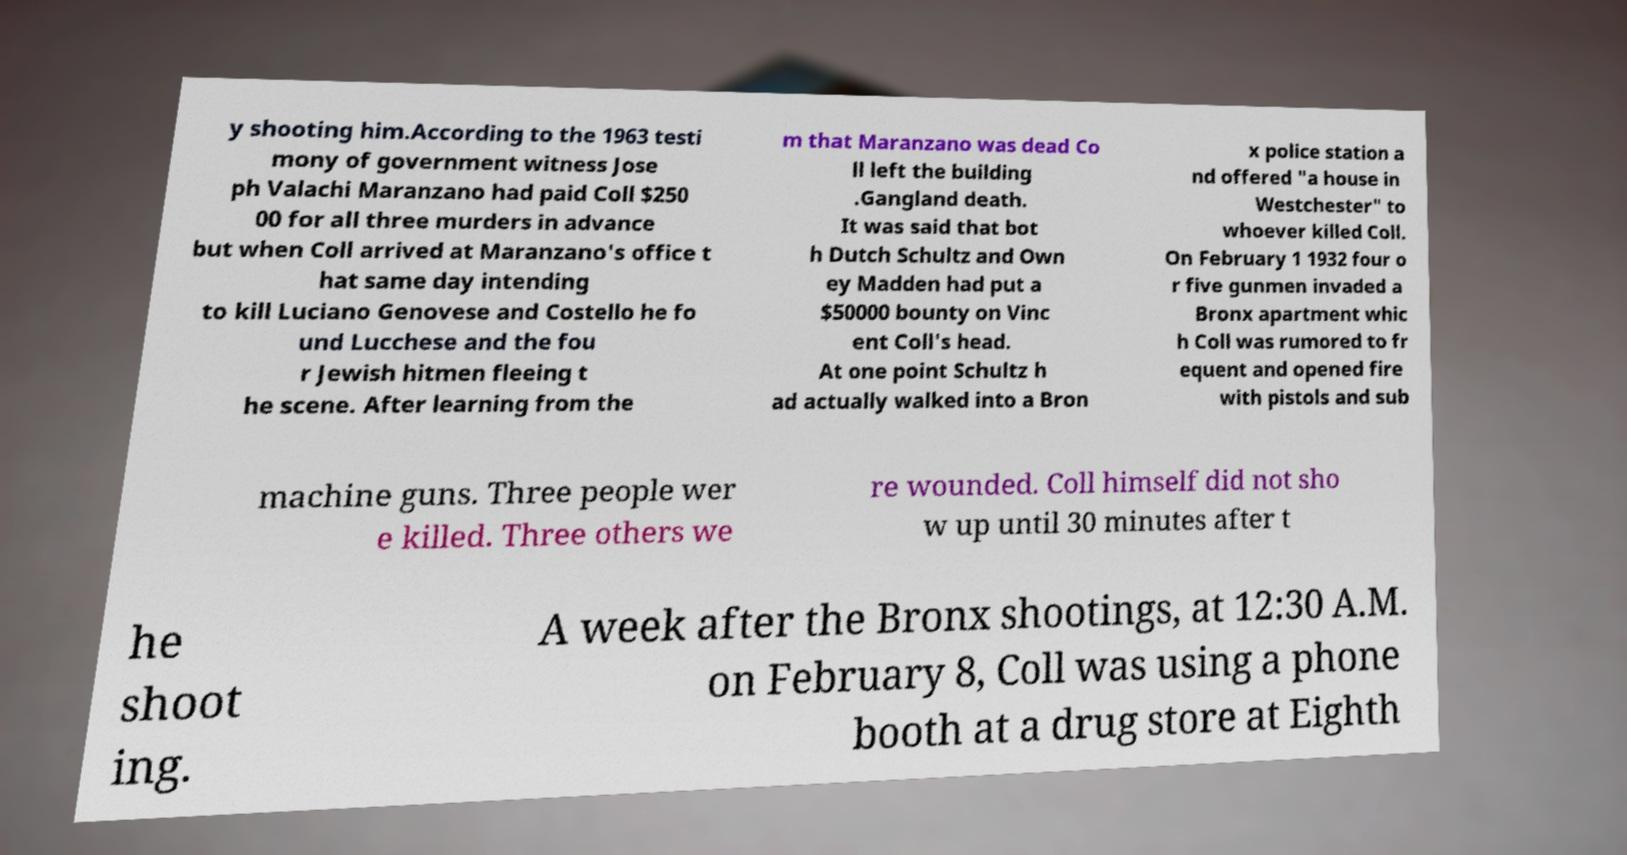I need the written content from this picture converted into text. Can you do that? y shooting him.According to the 1963 testi mony of government witness Jose ph Valachi Maranzano had paid Coll $250 00 for all three murders in advance but when Coll arrived at Maranzano's office t hat same day intending to kill Luciano Genovese and Costello he fo und Lucchese and the fou r Jewish hitmen fleeing t he scene. After learning from the m that Maranzano was dead Co ll left the building .Gangland death. It was said that bot h Dutch Schultz and Own ey Madden had put a $50000 bounty on Vinc ent Coll's head. At one point Schultz h ad actually walked into a Bron x police station a nd offered "a house in Westchester" to whoever killed Coll. On February 1 1932 four o r five gunmen invaded a Bronx apartment whic h Coll was rumored to fr equent and opened fire with pistols and sub machine guns. Three people wer e killed. Three others we re wounded. Coll himself did not sho w up until 30 minutes after t he shoot ing. A week after the Bronx shootings, at 12:30 A.M. on February 8, Coll was using a phone booth at a drug store at Eighth 